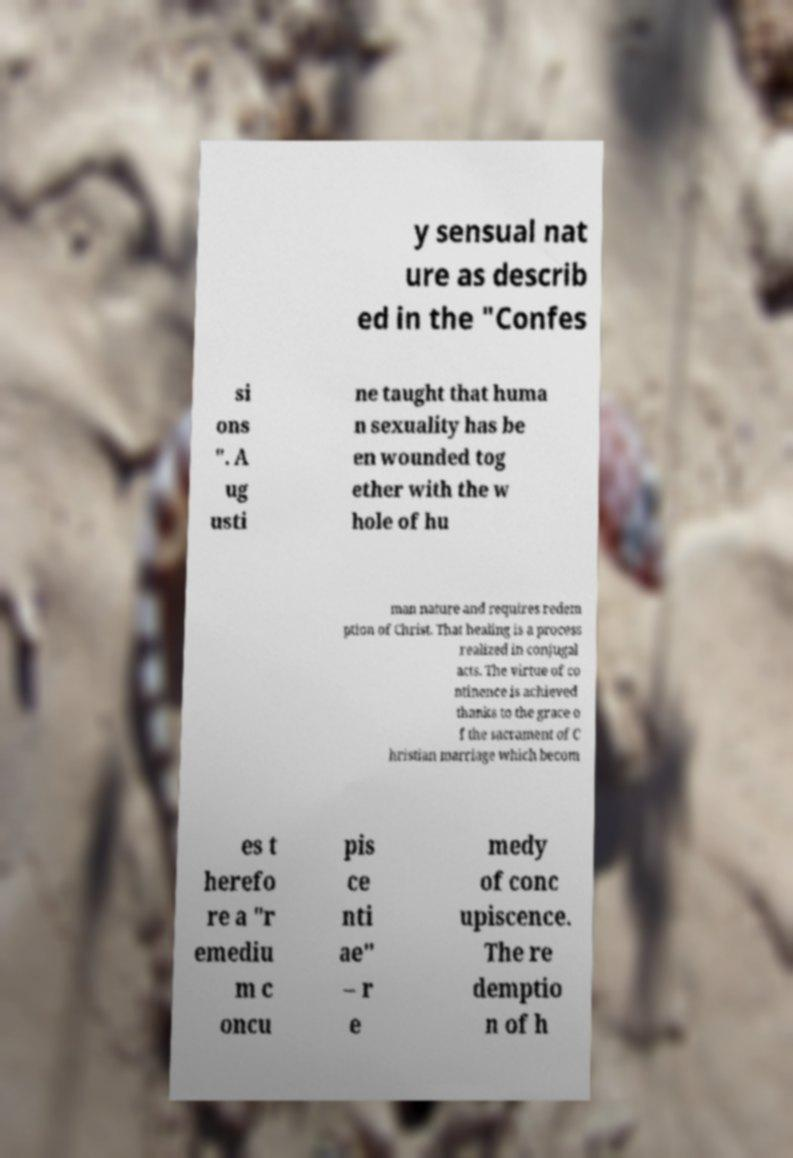For documentation purposes, I need the text within this image transcribed. Could you provide that? y sensual nat ure as describ ed in the "Confes si ons ". A ug usti ne taught that huma n sexuality has be en wounded tog ether with the w hole of hu man nature and requires redem ption of Christ. That healing is a process realized in conjugal acts. The virtue of co ntinence is achieved thanks to the grace o f the sacrament of C hristian marriage which becom es t herefo re a "r emediu m c oncu pis ce nti ae" – r e medy of conc upiscence. The re demptio n of h 